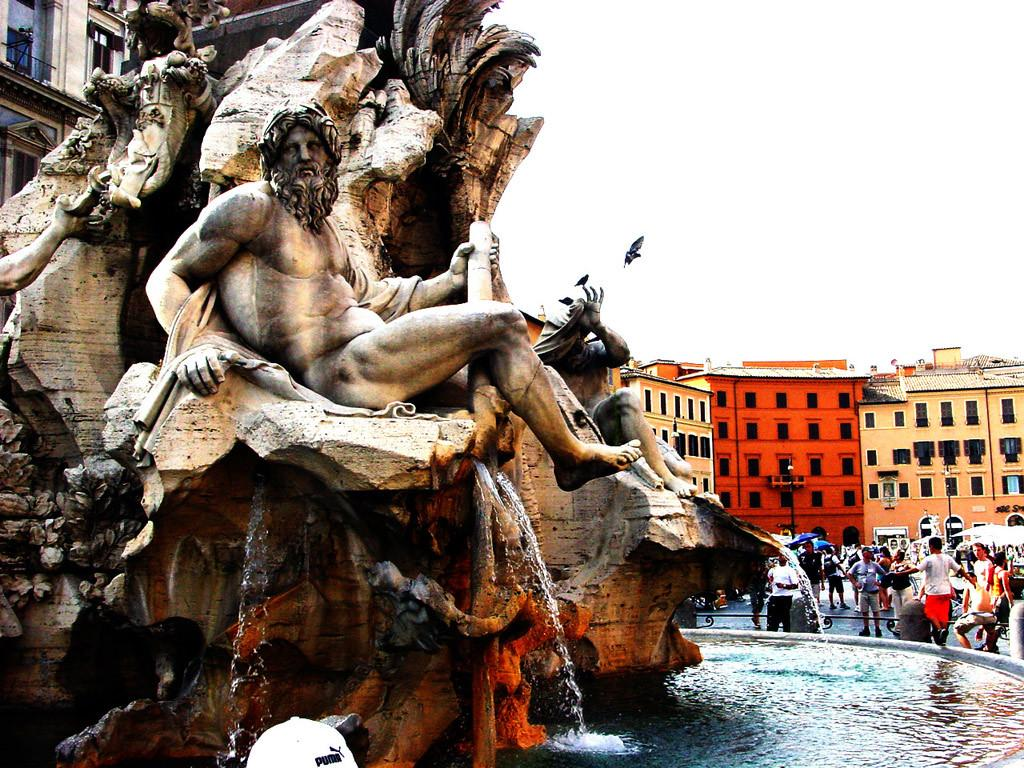What is on the fountain in the image? There are sculptures on the fountain in the image. What is the liquid element in the image? There is water in the image. What are people doing in the image? People are standing on the road in the image. What type of structures can be seen in the image? There are stalls and buildings visible in the image. What architectural features are present in the image? Street poles and railings are present in the image. What is flying in the air in the image? A bird is flying in the air in the image. What is visible in the background of the image? The sky is visible in the image. What type of loaf is being sold at the stalls in the image? There is no mention of a loaf or any food items being sold at the stalls in the image. What observation can be made about the feelings of the people standing on the road in the image? There is no information about the feelings of the people in the image, as we cannot determine their emotions from their body language or expressions. 